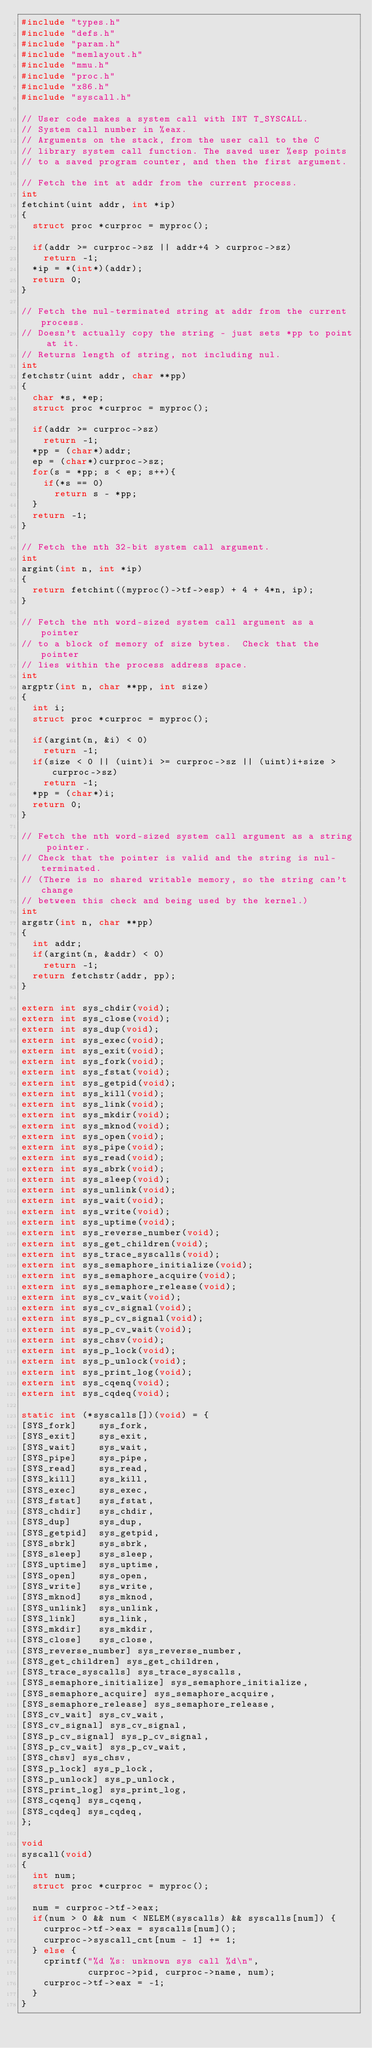<code> <loc_0><loc_0><loc_500><loc_500><_C_>#include "types.h"
#include "defs.h"
#include "param.h"
#include "memlayout.h"
#include "mmu.h"
#include "proc.h"
#include "x86.h"
#include "syscall.h"

// User code makes a system call with INT T_SYSCALL.
// System call number in %eax.
// Arguments on the stack, from the user call to the C
// library system call function. The saved user %esp points
// to a saved program counter, and then the first argument.

// Fetch the int at addr from the current process.
int
fetchint(uint addr, int *ip)
{
  struct proc *curproc = myproc();

  if(addr >= curproc->sz || addr+4 > curproc->sz)
    return -1;
  *ip = *(int*)(addr);
  return 0;
}

// Fetch the nul-terminated string at addr from the current process.
// Doesn't actually copy the string - just sets *pp to point at it.
// Returns length of string, not including nul.
int
fetchstr(uint addr, char **pp)
{
  char *s, *ep;
  struct proc *curproc = myproc();

  if(addr >= curproc->sz)
    return -1;
  *pp = (char*)addr;
  ep = (char*)curproc->sz;
  for(s = *pp; s < ep; s++){
    if(*s == 0)
      return s - *pp;
  }
  return -1;
}

// Fetch the nth 32-bit system call argument.
int
argint(int n, int *ip)
{
  return fetchint((myproc()->tf->esp) + 4 + 4*n, ip);
}

// Fetch the nth word-sized system call argument as a pointer
// to a block of memory of size bytes.  Check that the pointer
// lies within the process address space.
int
argptr(int n, char **pp, int size)
{
  int i;
  struct proc *curproc = myproc();
 
  if(argint(n, &i) < 0)
    return -1;
  if(size < 0 || (uint)i >= curproc->sz || (uint)i+size > curproc->sz)
    return -1;
  *pp = (char*)i;
  return 0;
}

// Fetch the nth word-sized system call argument as a string pointer.
// Check that the pointer is valid and the string is nul-terminated.
// (There is no shared writable memory, so the string can't change
// between this check and being used by the kernel.)
int
argstr(int n, char **pp)
{
  int addr;
  if(argint(n, &addr) < 0)
    return -1;
  return fetchstr(addr, pp);
}

extern int sys_chdir(void);
extern int sys_close(void);
extern int sys_dup(void);
extern int sys_exec(void);
extern int sys_exit(void);
extern int sys_fork(void);
extern int sys_fstat(void);
extern int sys_getpid(void);
extern int sys_kill(void);
extern int sys_link(void);
extern int sys_mkdir(void);
extern int sys_mknod(void);
extern int sys_open(void);
extern int sys_pipe(void);
extern int sys_read(void);
extern int sys_sbrk(void);
extern int sys_sleep(void);
extern int sys_unlink(void);
extern int sys_wait(void);
extern int sys_write(void);
extern int sys_uptime(void);
extern int sys_reverse_number(void);
extern int sys_get_children(void);
extern int sys_trace_syscalls(void);
extern int sys_semaphore_initialize(void);
extern int sys_semaphore_acquire(void);
extern int sys_semaphore_release(void);
extern int sys_cv_wait(void);
extern int sys_cv_signal(void);
extern int sys_p_cv_signal(void);
extern int sys_p_cv_wait(void);
extern int sys_chsv(void);
extern int sys_p_lock(void);
extern int sys_p_unlock(void);
extern int sys_print_log(void);
extern int sys_cqenq(void);
extern int sys_cqdeq(void);

static int (*syscalls[])(void) = {
[SYS_fork]    sys_fork,
[SYS_exit]    sys_exit,
[SYS_wait]    sys_wait,
[SYS_pipe]    sys_pipe,
[SYS_read]    sys_read,
[SYS_kill]    sys_kill,
[SYS_exec]    sys_exec,
[SYS_fstat]   sys_fstat,
[SYS_chdir]   sys_chdir,
[SYS_dup]     sys_dup,
[SYS_getpid]  sys_getpid,
[SYS_sbrk]    sys_sbrk,
[SYS_sleep]   sys_sleep,
[SYS_uptime]  sys_uptime,
[SYS_open]    sys_open,
[SYS_write]   sys_write,
[SYS_mknod]   sys_mknod,
[SYS_unlink]  sys_unlink,
[SYS_link]    sys_link,
[SYS_mkdir]   sys_mkdir,
[SYS_close]   sys_close,
[SYS_reverse_number] sys_reverse_number,
[SYS_get_children] sys_get_children,
[SYS_trace_syscalls] sys_trace_syscalls,
[SYS_semaphore_initialize] sys_semaphore_initialize,
[SYS_semaphore_acquire] sys_semaphore_acquire,
[SYS_semaphore_release] sys_semaphore_release,
[SYS_cv_wait] sys_cv_wait,
[SYS_cv_signal] sys_cv_signal,
[SYS_p_cv_signal] sys_p_cv_signal,
[SYS_p_cv_wait] sys_p_cv_wait,
[SYS_chsv] sys_chsv,
[SYS_p_lock] sys_p_lock,
[SYS_p_unlock] sys_p_unlock,
[SYS_print_log] sys_print_log,
[SYS_cqenq] sys_cqenq,
[SYS_cqdeq] sys_cqdeq,
};

void
syscall(void)
{
  int num;
  struct proc *curproc = myproc();

  num = curproc->tf->eax;
  if(num > 0 && num < NELEM(syscalls) && syscalls[num]) {
    curproc->tf->eax = syscalls[num]();
    curproc->syscall_cnt[num - 1] += 1;
  } else {
    cprintf("%d %s: unknown sys call %d\n",
            curproc->pid, curproc->name, num);
    curproc->tf->eax = -1;
  }
}
</code> 